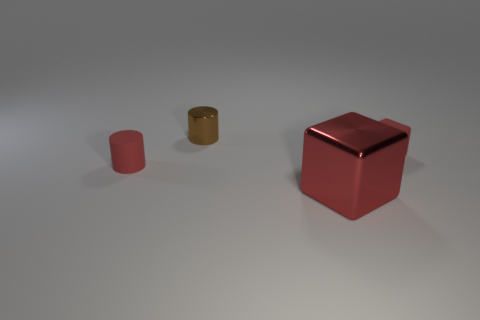How many red cubes must be subtracted to get 1 red cubes? 1 Add 3 tiny red rubber cylinders. How many objects exist? 7 Add 3 red metal objects. How many red metal objects are left? 4 Add 2 tiny brown metallic cylinders. How many tiny brown metallic cylinders exist? 3 Subtract 0 blue cubes. How many objects are left? 4 Subtract all blue balls. Subtract all large shiny objects. How many objects are left? 3 